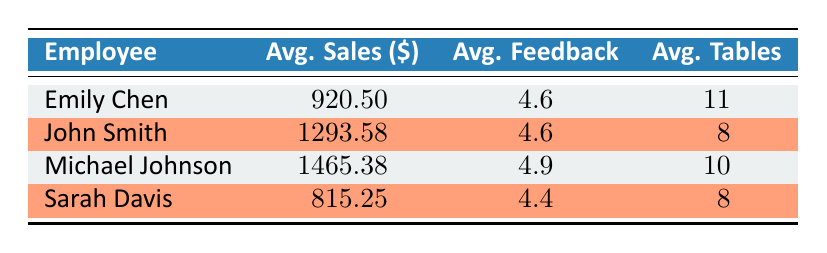What is the average sales amount for Sarah Davis? From the table, Sarah Davis has average sales of 815.25. This value is directly presented under the "Avg. Sales ($)" column for Sarah Davis.
Answer: 815.25 Who has the highest average customer feedback score? Examining the "Avg. Feedback" column, Michael Johnson has the highest score at 4.9 compared to the others.
Answer: Michael Johnson What is the total average sales for all staff members combined? To find the total average sales, add up all average sales: 920.50 + 1293.58 + 1465.38 + 815.25 = 3494.71. Then, divide by the number of employees (4), giving 3494.71 / 4 = 873.68.
Answer: 873.68 Is Emily Chen's average sales greater than John Smith's? By comparing the average sales for Emily Chen (920.50) and John Smith (1293.58), we find that John Smith's sales are greater than Emily Chen's. Therefore, the statement is false.
Answer: No What is the average number of tables served by Michael Johnson? The average number of tables served by Michael Johnson is presented under the "Avg. Tables" column, which shows a value of 10.
Answer: 10 Which employee has the lowest average feedback score, and what is that score? By reviewing the "Avg. Feedback" column, Sarah Davis has the lowest score at 4.4. Thus, the employee is Sarah Davis with 4.4 as the score.
Answer: Sarah Davis, 4.4 What is the average sales difference between John Smith and Michael Johnson? John Smith's average sales are 1293.58, and Michael Johnson's are 1465.38. The difference is calculated as 1465.38 - 1293.58 = 171.80.
Answer: 171.80 Are the average sales for John Smith and Sarah Davis both above 1000? Checking their average sales, John Smith has 1293.58 (above 1000), but Sarah Davis has 815.25 (not above 1000). Therefore, the statement is false.
Answer: No 